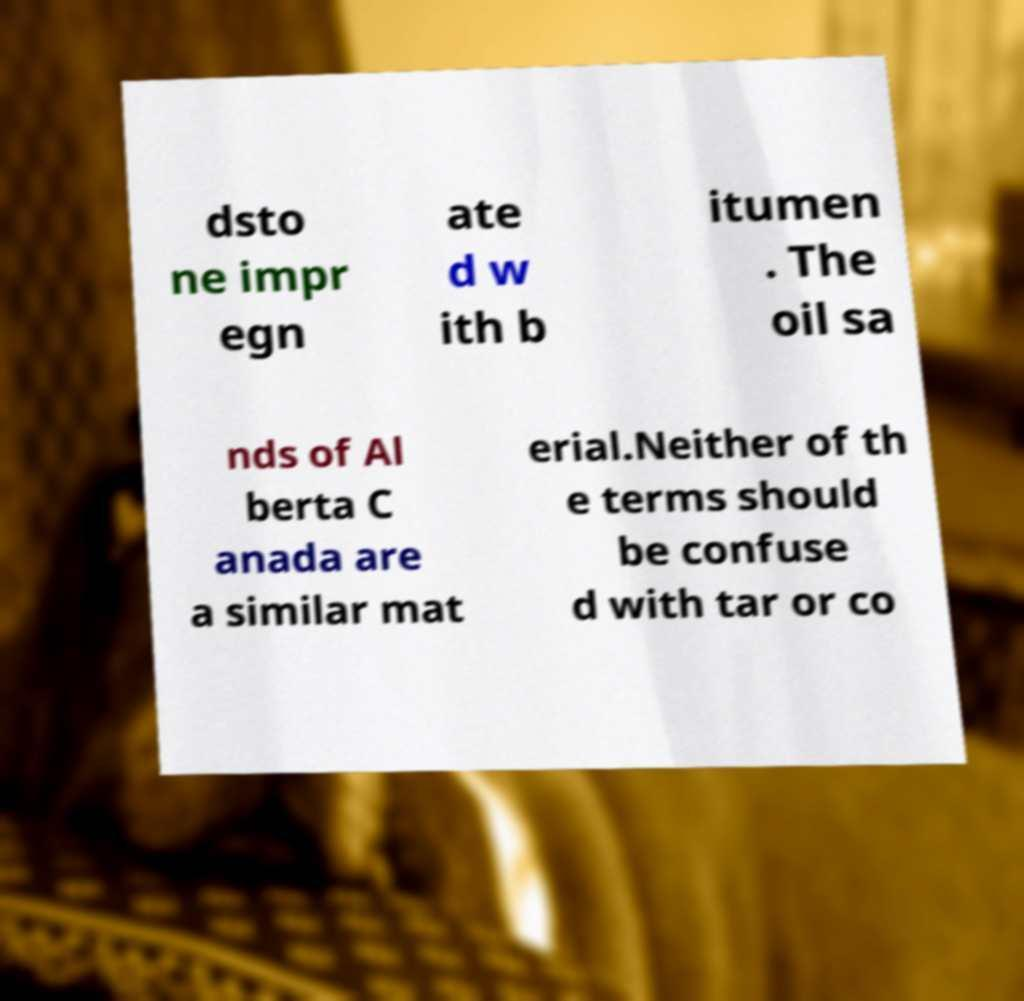What messages or text are displayed in this image? I need them in a readable, typed format. dsto ne impr egn ate d w ith b itumen . The oil sa nds of Al berta C anada are a similar mat erial.Neither of th e terms should be confuse d with tar or co 